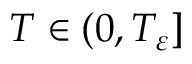Convert formula to latex. <formula><loc_0><loc_0><loc_500><loc_500>T \in ( 0 , T _ { \varepsilon } ]</formula> 